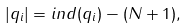<formula> <loc_0><loc_0><loc_500><loc_500>| q _ { i } | = i n d ( q _ { i } ) - ( N + 1 ) ,</formula> 